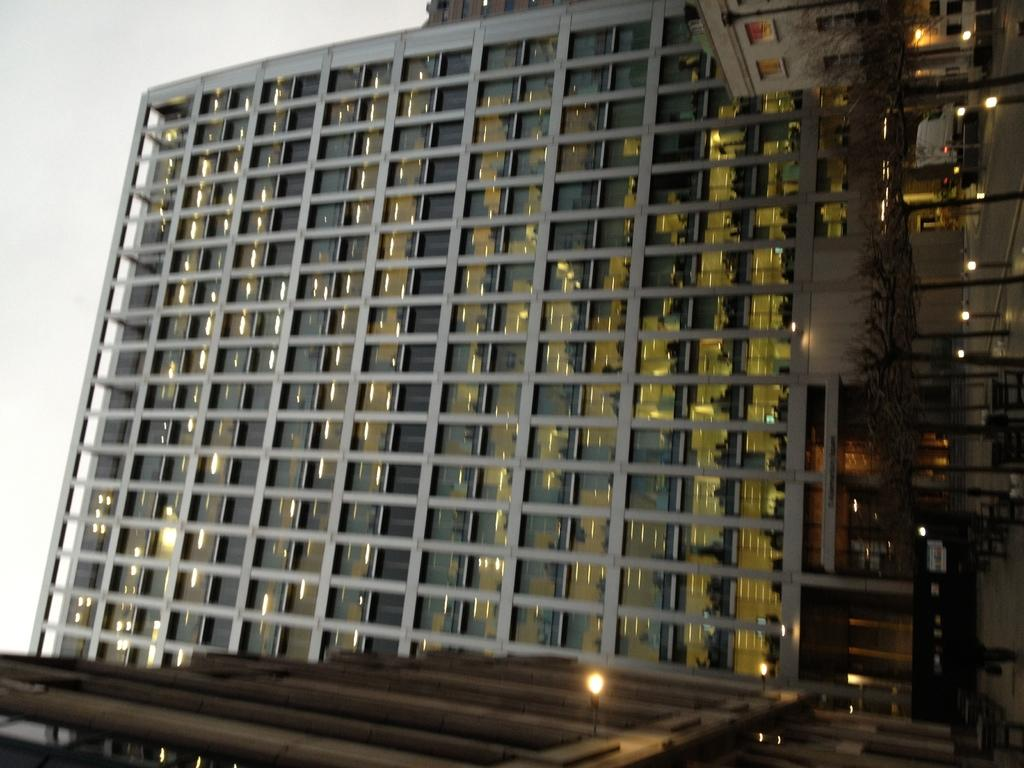Where was the picture taken? The picture was clicked outside. What can be seen in the foreground of the image? There are lights and other objects in the foreground of the image. What is visible in the background of the image? The sky, buildings, additional lights, and many other objects are visible in the background of the image. What type of weather can be seen in the image? The provided facts do not mention any specific weather conditions, so it cannot be determined from the image. How many bushes are present in the image? There is no mention of bushes in the provided facts, so it cannot be determined from the image. 